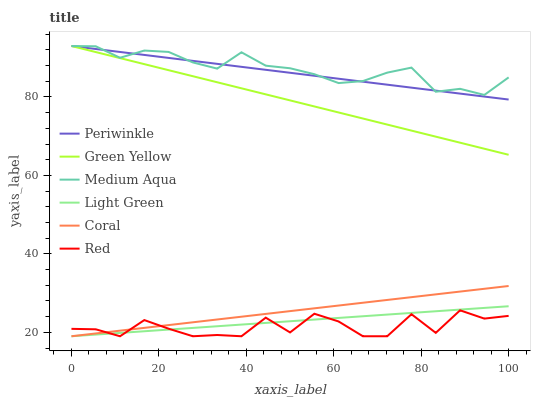Does Red have the minimum area under the curve?
Answer yes or no. Yes. Does Medium Aqua have the maximum area under the curve?
Answer yes or no. Yes. Does Light Green have the minimum area under the curve?
Answer yes or no. No. Does Light Green have the maximum area under the curve?
Answer yes or no. No. Is Light Green the smoothest?
Answer yes or no. Yes. Is Red the roughest?
Answer yes or no. Yes. Is Medium Aqua the smoothest?
Answer yes or no. No. Is Medium Aqua the roughest?
Answer yes or no. No. Does Coral have the lowest value?
Answer yes or no. Yes. Does Medium Aqua have the lowest value?
Answer yes or no. No. Does Green Yellow have the highest value?
Answer yes or no. Yes. Does Light Green have the highest value?
Answer yes or no. No. Is Red less than Medium Aqua?
Answer yes or no. Yes. Is Medium Aqua greater than Red?
Answer yes or no. Yes. Does Periwinkle intersect Green Yellow?
Answer yes or no. Yes. Is Periwinkle less than Green Yellow?
Answer yes or no. No. Is Periwinkle greater than Green Yellow?
Answer yes or no. No. Does Red intersect Medium Aqua?
Answer yes or no. No. 